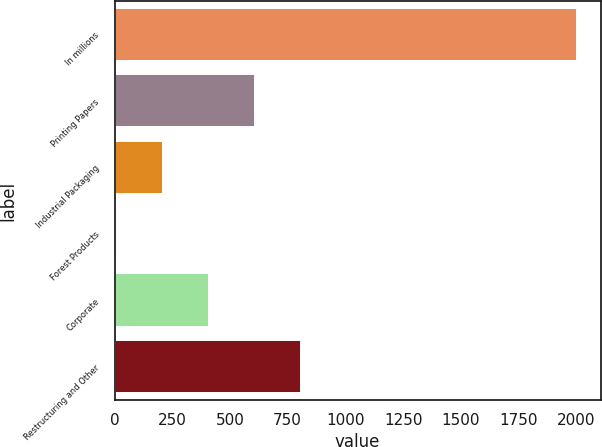Convert chart. <chart><loc_0><loc_0><loc_500><loc_500><bar_chart><fcel>In millions<fcel>Printing Papers<fcel>Industrial Packaging<fcel>Forest Products<fcel>Corporate<fcel>Restructuring and Other<nl><fcel>2005<fcel>609.9<fcel>211.3<fcel>12<fcel>410.6<fcel>809.2<nl></chart> 